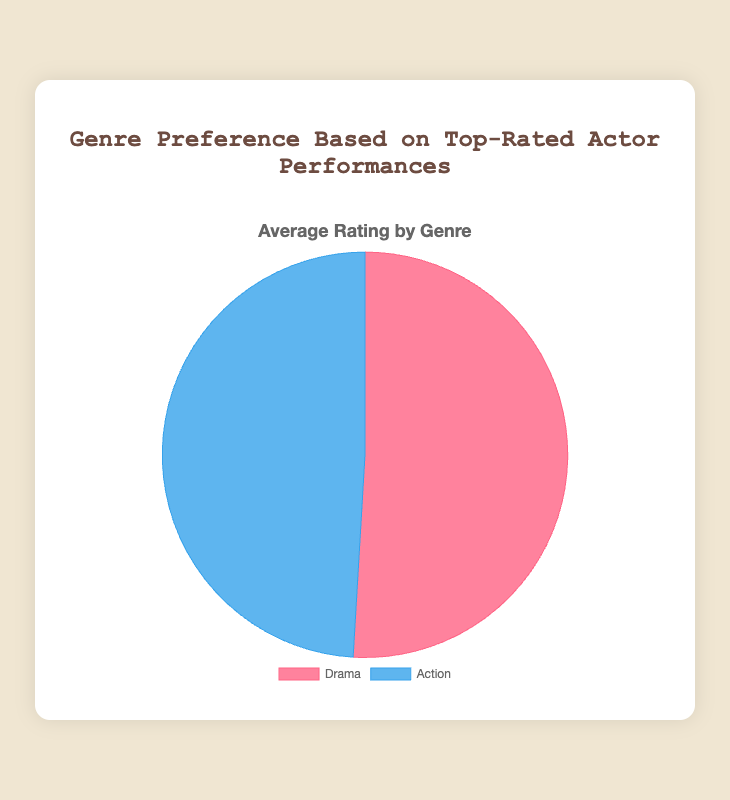Which genre has the higher average rating? By looking at the pie chart, we can compare the sizes of the slices. The slice representing Drama is larger than the slice representing Action, indicating that Drama has a higher average rating.
Answer: Drama What is the average rating of the Drama genre? From the pie chart's tooltip, when hovering over the Drama slice, it shows the average rating.
Answer: 8.2 What is the average rating of the Action genre? From the pie chart's tooltip, when hovering over the Action slice, it shows the average rating.
Answer: 7.9 By how much does the average rating of Drama exceed that of Action? First, identify the average ratings: Drama is 8.2 and Action is 7.9. Then, subtract the Action rating from the Drama rating: 8.2 - 7.9.
Answer: 0.3 What is the total average rating of both genres combined? Add the average ratings of Drama and Action: 8.2 + 7.9 = 16.1. Since there are two genres, divide the sum by 2 to find the total average: 16.1 / 2.
Answer: 8.05 Which slice is visually larger in the pie chart? By observing the pie chart, we can see that the slice representing Drama is visually larger than the one for Action.
Answer: Drama What are the colors representing Drama and Action in the pie chart? The pie chart uses color coding to distinguish between genres. Drama is represented by red, and Action is represented by blue.
Answer: Red for Drama, Blue for Action What percentage of the pie chart does the Drama genre cover? The pie chart divides the total into parts. Drama's larger slice would cover approximately 50% more of the circle compared to Action's smaller, just over 44.85%.
Answer: Approximately 55% Which actor has the highest-rated performance in the Drama genre? From the dataset provided, the highest rating for a performance in the Drama genre is Meryl Streep in "The Iron Lady" with a rating of 8.6.
Answer: Meryl Streep Which actor has the lowest-rated performance in the Action genre? From the dataset provided, the lowest rating for a performance in the Action genre is Tom Cruise in "Mission: Impossible - Fallout" with a rating of 7.7.
Answer: Tom Cruise 